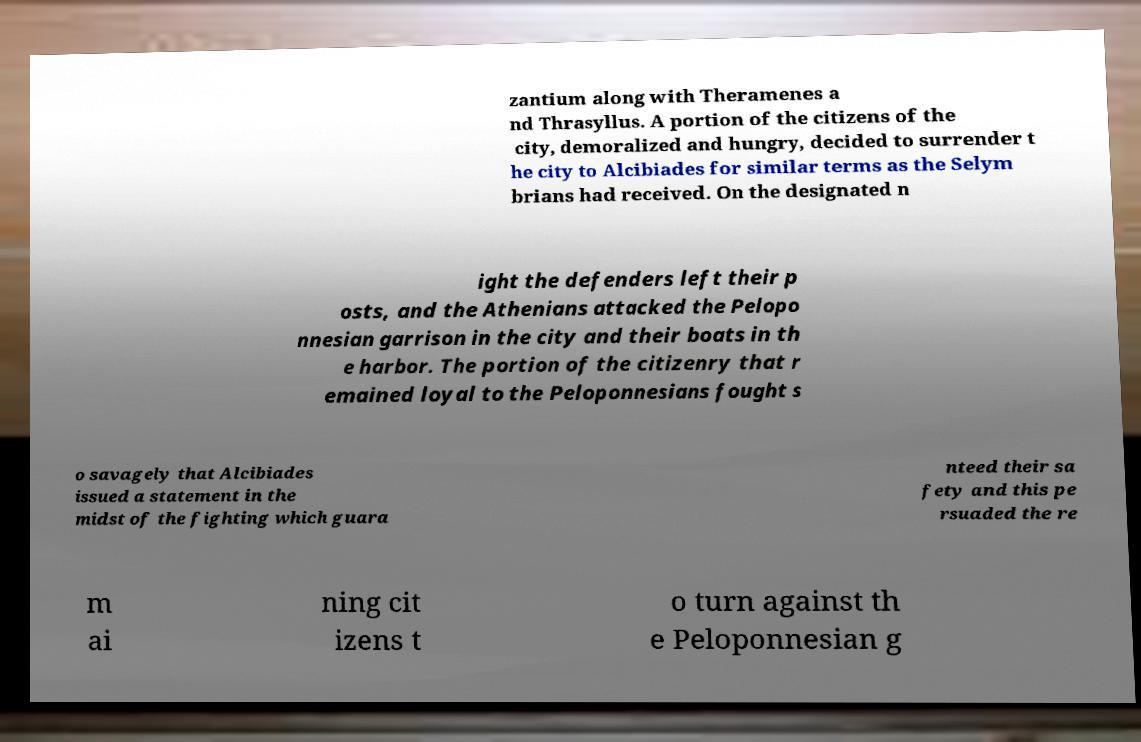Could you assist in decoding the text presented in this image and type it out clearly? zantium along with Theramenes a nd Thrasyllus. A portion of the citizens of the city, demoralized and hungry, decided to surrender t he city to Alcibiades for similar terms as the Selym brians had received. On the designated n ight the defenders left their p osts, and the Athenians attacked the Pelopo nnesian garrison in the city and their boats in th e harbor. The portion of the citizenry that r emained loyal to the Peloponnesians fought s o savagely that Alcibiades issued a statement in the midst of the fighting which guara nteed their sa fety and this pe rsuaded the re m ai ning cit izens t o turn against th e Peloponnesian g 